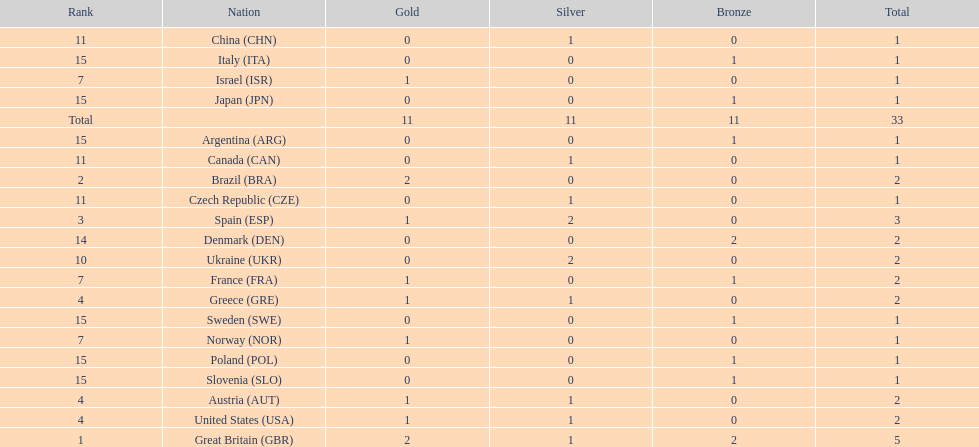How many gold medals did italy receive? 0. 